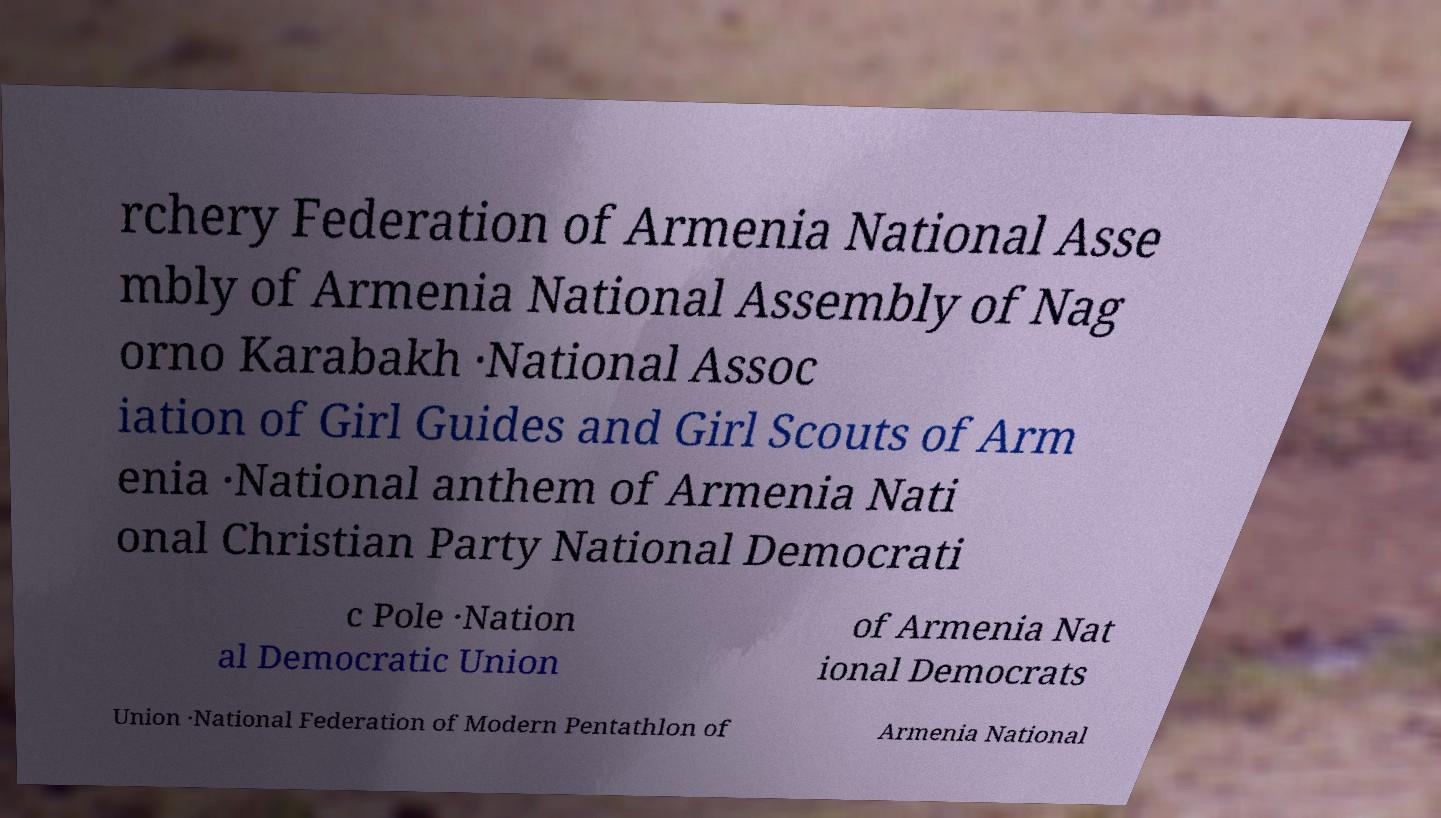Could you assist in decoding the text presented in this image and type it out clearly? rchery Federation of Armenia National Asse mbly of Armenia National Assembly of Nag orno Karabakh ·National Assoc iation of Girl Guides and Girl Scouts of Arm enia ·National anthem of Armenia Nati onal Christian Party National Democrati c Pole ·Nation al Democratic Union of Armenia Nat ional Democrats Union ·National Federation of Modern Pentathlon of Armenia National 